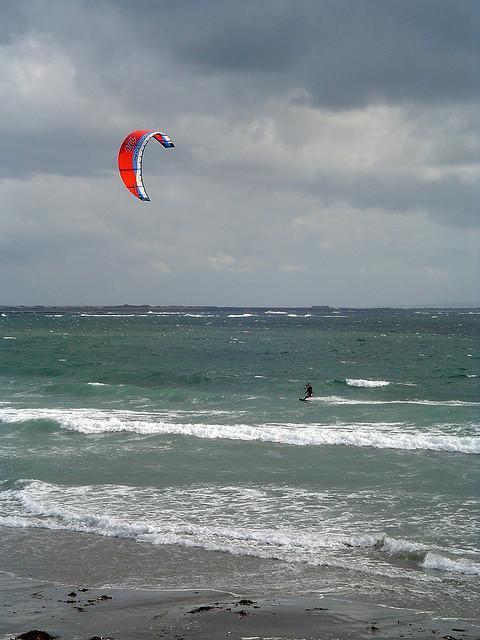How many people are pictured?
Give a very brief answer. 1. How many cakes are there?
Give a very brief answer. 0. 